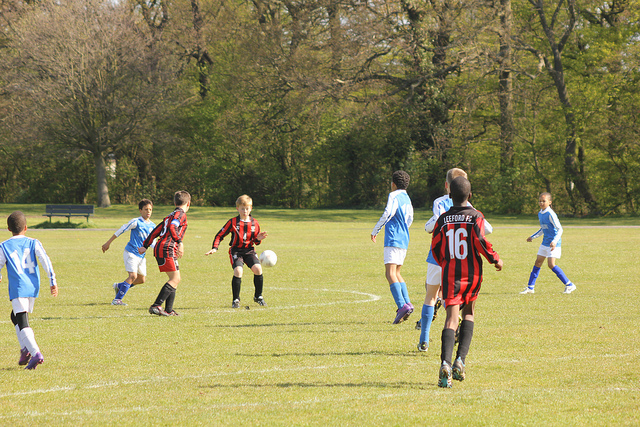Identify the text displayed in this image. 16 